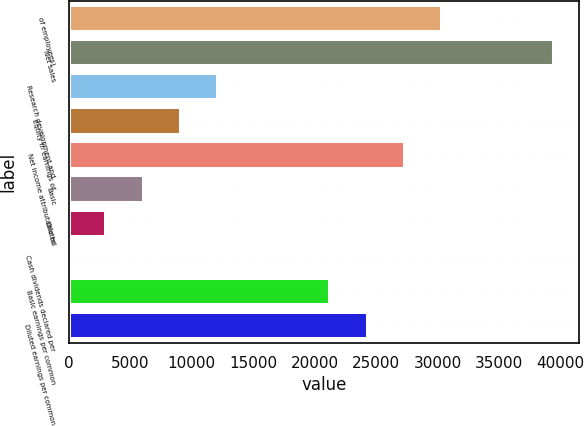<chart> <loc_0><loc_0><loc_500><loc_500><bar_chart><fcel>of employees)<fcel>Net sales<fcel>Research development and<fcel>Equity in earnings of<fcel>Net income attributable to<fcel>Basic<fcel>Diluted<fcel>Cash dividends declared per<fcel>Basic earnings per common<fcel>Diluted earnings per common<nl><fcel>30400<fcel>39519.9<fcel>12160.2<fcel>9120.27<fcel>27360<fcel>6080.31<fcel>3040.35<fcel>0.39<fcel>21280.1<fcel>24320.1<nl></chart> 